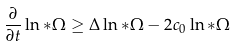<formula> <loc_0><loc_0><loc_500><loc_500>\frac { \partial } { \partial t } \ln * \Omega \geq \Delta \ln * \Omega - 2 c _ { 0 } \ln * \Omega</formula> 